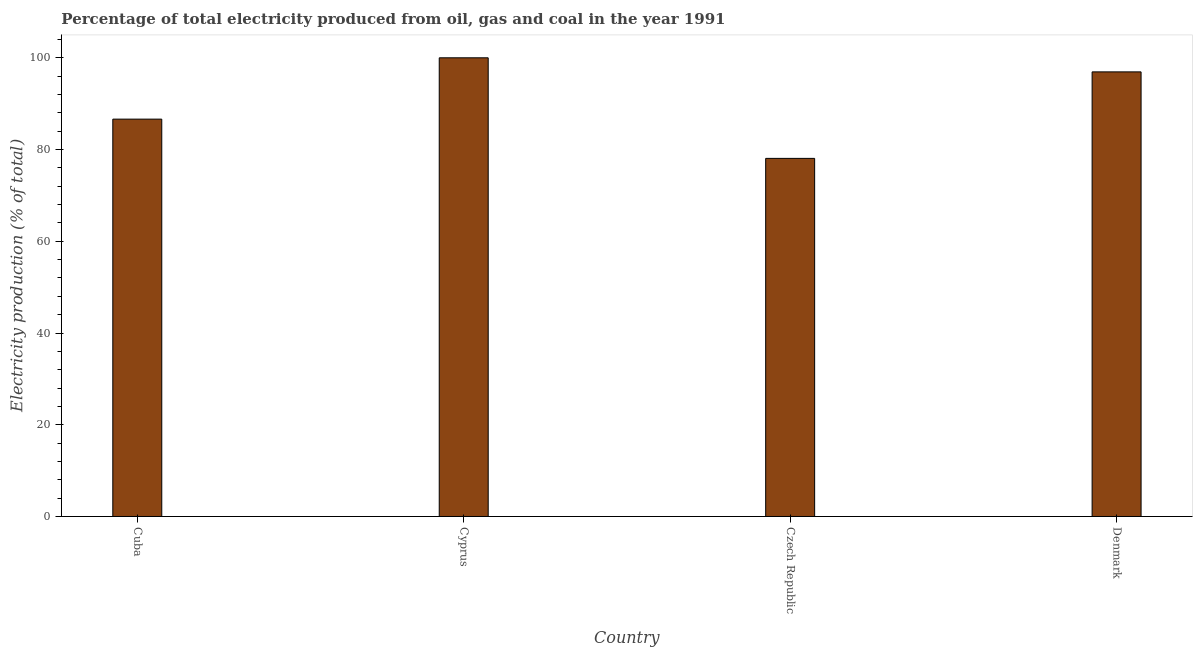Does the graph contain grids?
Offer a very short reply. No. What is the title of the graph?
Provide a short and direct response. Percentage of total electricity produced from oil, gas and coal in the year 1991. What is the label or title of the Y-axis?
Keep it short and to the point. Electricity production (% of total). What is the electricity production in Denmark?
Offer a terse response. 96.93. Across all countries, what is the minimum electricity production?
Your response must be concise. 78.07. In which country was the electricity production maximum?
Give a very brief answer. Cyprus. In which country was the electricity production minimum?
Give a very brief answer. Czech Republic. What is the sum of the electricity production?
Your answer should be very brief. 361.64. What is the difference between the electricity production in Cuba and Denmark?
Offer a terse response. -10.3. What is the average electricity production per country?
Your answer should be compact. 90.41. What is the median electricity production?
Your answer should be very brief. 91.78. What is the ratio of the electricity production in Cuba to that in Czech Republic?
Offer a terse response. 1.11. Is the electricity production in Cuba less than that in Denmark?
Make the answer very short. Yes. Is the difference between the electricity production in Cyprus and Czech Republic greater than the difference between any two countries?
Your answer should be compact. Yes. What is the difference between the highest and the second highest electricity production?
Your answer should be compact. 3.07. What is the difference between the highest and the lowest electricity production?
Your answer should be very brief. 21.93. In how many countries, is the electricity production greater than the average electricity production taken over all countries?
Ensure brevity in your answer.  2. How many bars are there?
Provide a succinct answer. 4. Are all the bars in the graph horizontal?
Provide a short and direct response. No. How many countries are there in the graph?
Ensure brevity in your answer.  4. What is the Electricity production (% of total) of Cuba?
Provide a short and direct response. 86.63. What is the Electricity production (% of total) of Czech Republic?
Make the answer very short. 78.07. What is the Electricity production (% of total) in Denmark?
Offer a very short reply. 96.93. What is the difference between the Electricity production (% of total) in Cuba and Cyprus?
Provide a succinct answer. -13.37. What is the difference between the Electricity production (% of total) in Cuba and Czech Republic?
Your answer should be compact. 8.56. What is the difference between the Electricity production (% of total) in Cuba and Denmark?
Your response must be concise. -10.3. What is the difference between the Electricity production (% of total) in Cyprus and Czech Republic?
Your response must be concise. 21.93. What is the difference between the Electricity production (% of total) in Cyprus and Denmark?
Provide a succinct answer. 3.07. What is the difference between the Electricity production (% of total) in Czech Republic and Denmark?
Keep it short and to the point. -18.86. What is the ratio of the Electricity production (% of total) in Cuba to that in Cyprus?
Give a very brief answer. 0.87. What is the ratio of the Electricity production (% of total) in Cuba to that in Czech Republic?
Give a very brief answer. 1.11. What is the ratio of the Electricity production (% of total) in Cuba to that in Denmark?
Ensure brevity in your answer.  0.89. What is the ratio of the Electricity production (% of total) in Cyprus to that in Czech Republic?
Your answer should be compact. 1.28. What is the ratio of the Electricity production (% of total) in Cyprus to that in Denmark?
Your response must be concise. 1.03. What is the ratio of the Electricity production (% of total) in Czech Republic to that in Denmark?
Your answer should be very brief. 0.81. 